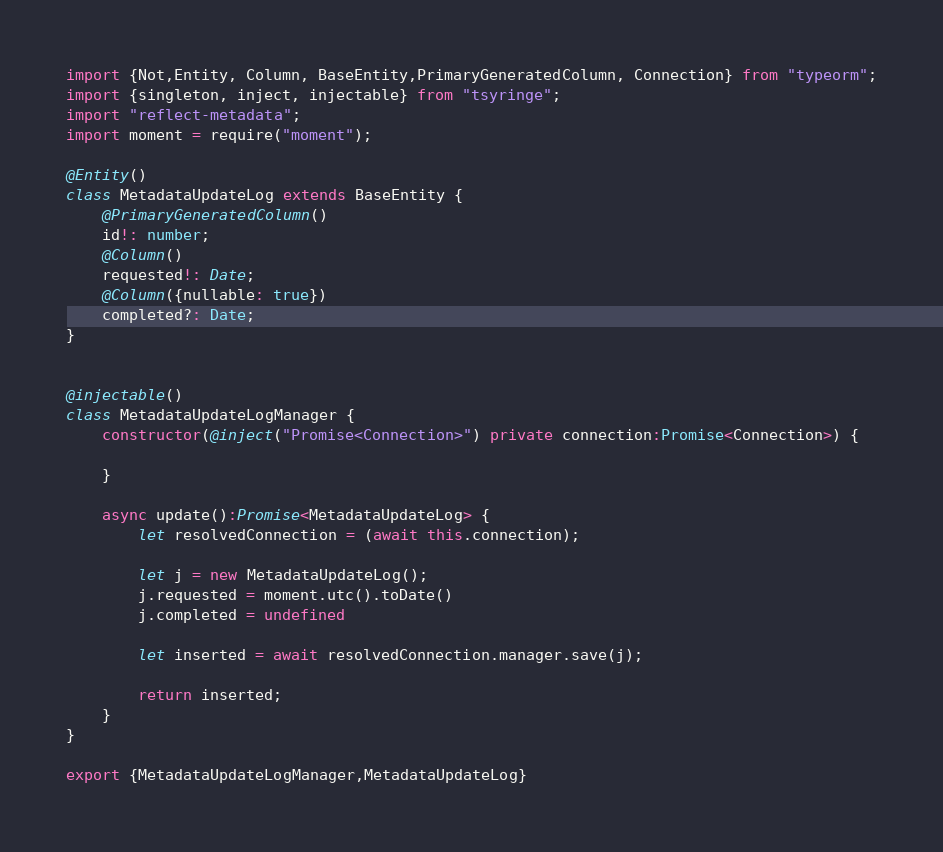<code> <loc_0><loc_0><loc_500><loc_500><_TypeScript_>import {Not,Entity, Column, BaseEntity,PrimaryGeneratedColumn, Connection} from "typeorm";
import {singleton, inject, injectable} from "tsyringe";
import "reflect-metadata";
import moment = require("moment");

@Entity()
class MetadataUpdateLog extends BaseEntity {
    @PrimaryGeneratedColumn()
    id!: number;
    @Column()
    requested!: Date;
    @Column({nullable: true})
    completed?: Date;
}


@injectable()
class MetadataUpdateLogManager {
    constructor(@inject("Promise<Connection>") private connection:Promise<Connection>) {

    }

    async update():Promise<MetadataUpdateLog> {
        let resolvedConnection = (await this.connection);

        let j = new MetadataUpdateLog();
        j.requested = moment.utc().toDate()
        j.completed = undefined
        
        let inserted = await resolvedConnection.manager.save(j);

        return inserted;
    }
}

export {MetadataUpdateLogManager,MetadataUpdateLog}</code> 